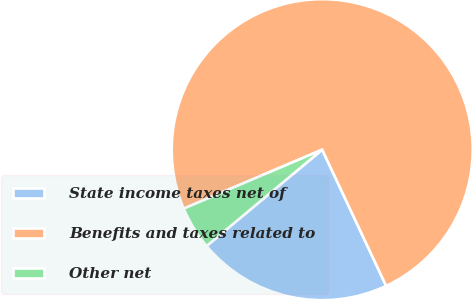<chart> <loc_0><loc_0><loc_500><loc_500><pie_chart><fcel>State income taxes net of<fcel>Benefits and taxes related to<fcel>Other net<nl><fcel>20.93%<fcel>74.42%<fcel>4.65%<nl></chart> 